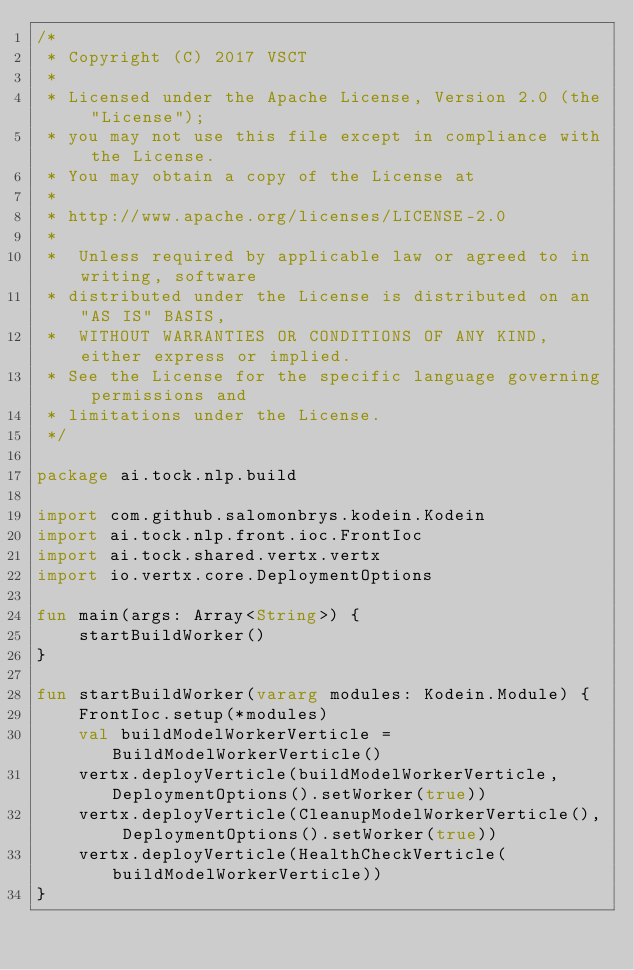<code> <loc_0><loc_0><loc_500><loc_500><_Kotlin_>/*
 * Copyright (C) 2017 VSCT
 *
 * Licensed under the Apache License, Version 2.0 (the "License");
 * you may not use this file except in compliance with the License.
 * You may obtain a copy of the License at
 *
 * http://www.apache.org/licenses/LICENSE-2.0
 *
 *  Unless required by applicable law or agreed to in writing, software
 * distributed under the License is distributed on an "AS IS" BASIS,
 *  WITHOUT WARRANTIES OR CONDITIONS OF ANY KIND, either express or implied.
 * See the License for the specific language governing permissions and
 * limitations under the License.
 */

package ai.tock.nlp.build

import com.github.salomonbrys.kodein.Kodein
import ai.tock.nlp.front.ioc.FrontIoc
import ai.tock.shared.vertx.vertx
import io.vertx.core.DeploymentOptions

fun main(args: Array<String>) {
    startBuildWorker()
}

fun startBuildWorker(vararg modules: Kodein.Module) {
    FrontIoc.setup(*modules)
    val buildModelWorkerVerticle = BuildModelWorkerVerticle()
    vertx.deployVerticle(buildModelWorkerVerticle, DeploymentOptions().setWorker(true))
    vertx.deployVerticle(CleanupModelWorkerVerticle(), DeploymentOptions().setWorker(true))
    vertx.deployVerticle(HealthCheckVerticle(buildModelWorkerVerticle))
}

</code> 